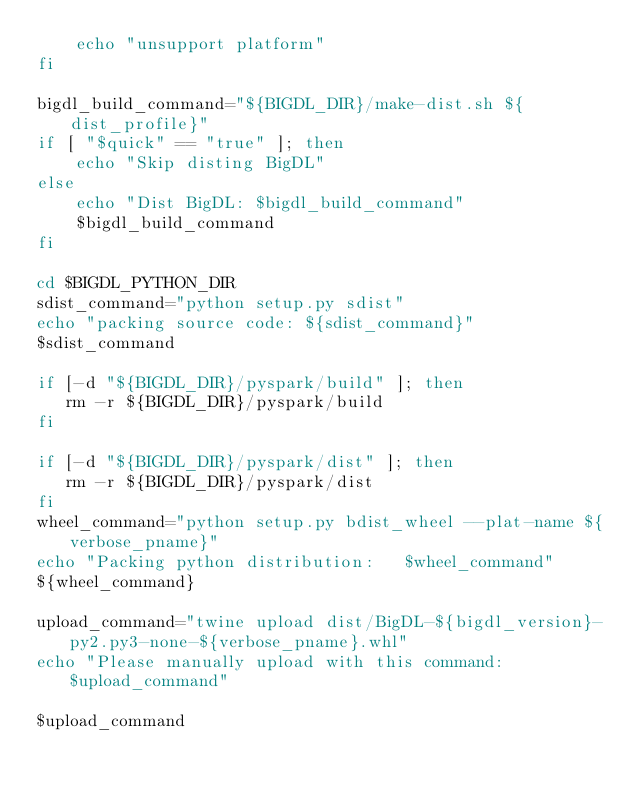<code> <loc_0><loc_0><loc_500><loc_500><_Bash_>    echo "unsupport platform"
fi

bigdl_build_command="${BIGDL_DIR}/make-dist.sh ${dist_profile}"
if [ "$quick" == "true" ]; then
    echo "Skip disting BigDL"
else
    echo "Dist BigDL: $bigdl_build_command"
    $bigdl_build_command
fi

cd $BIGDL_PYTHON_DIR
sdist_command="python setup.py sdist"
echo "packing source code: ${sdist_command}"
$sdist_command

if [-d "${BIGDL_DIR}/pyspark/build" ]; then
   rm -r ${BIGDL_DIR}/pyspark/build
fi

if [-d "${BIGDL_DIR}/pyspark/dist" ]; then
   rm -r ${BIGDL_DIR}/pyspark/dist
fi
wheel_command="python setup.py bdist_wheel --plat-name ${verbose_pname}"
echo "Packing python distribution:   $wheel_command"
${wheel_command}

upload_command="twine upload dist/BigDL-${bigdl_version}-py2.py3-none-${verbose_pname}.whl"
echo "Please manually upload with this command:  $upload_command"

$upload_command
</code> 